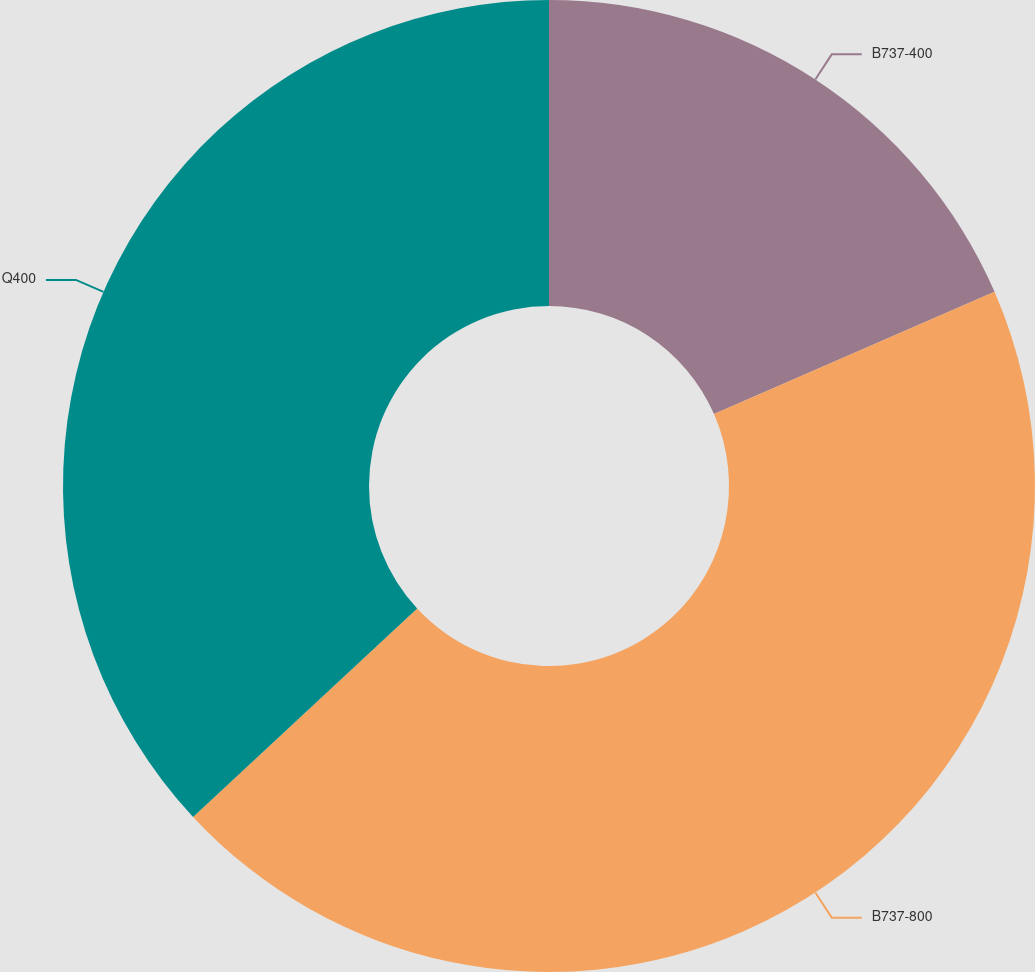Convert chart to OTSL. <chart><loc_0><loc_0><loc_500><loc_500><pie_chart><fcel>B737-400<fcel>B737-800<fcel>Q400<nl><fcel>18.46%<fcel>44.62%<fcel>36.92%<nl></chart> 